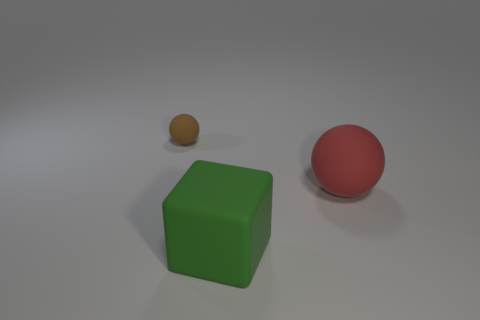Add 1 green cubes. How many objects exist? 4 Subtract 2 spheres. How many spheres are left? 0 Subtract all green balls. Subtract all green cubes. How many balls are left? 2 Subtract all purple cylinders. How many red spheres are left? 1 Subtract all red rubber objects. Subtract all green things. How many objects are left? 1 Add 1 large matte cubes. How many large matte cubes are left? 2 Add 2 tiny matte things. How many tiny matte things exist? 3 Subtract 0 red cylinders. How many objects are left? 3 Subtract all balls. How many objects are left? 1 